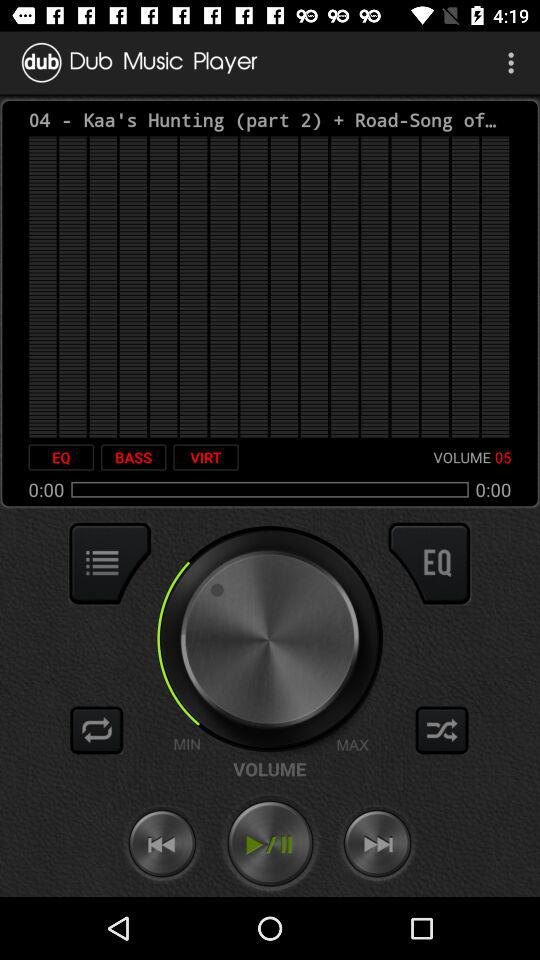What is the application name? The application name is "Dub Music Player". 